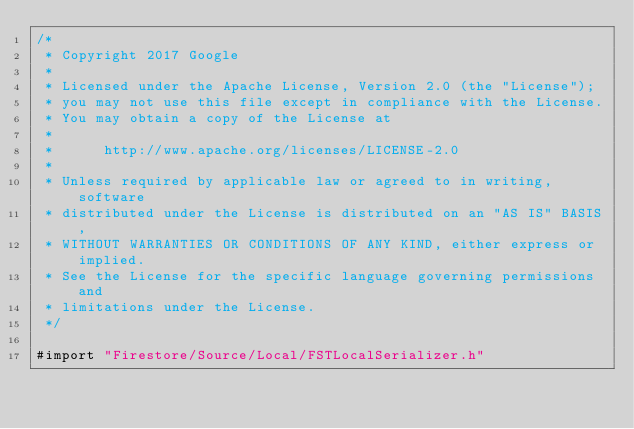Convert code to text. <code><loc_0><loc_0><loc_500><loc_500><_ObjectiveC_>/*
 * Copyright 2017 Google
 *
 * Licensed under the Apache License, Version 2.0 (the "License");
 * you may not use this file except in compliance with the License.
 * You may obtain a copy of the License at
 *
 *      http://www.apache.org/licenses/LICENSE-2.0
 *
 * Unless required by applicable law or agreed to in writing, software
 * distributed under the License is distributed on an "AS IS" BASIS,
 * WITHOUT WARRANTIES OR CONDITIONS OF ANY KIND, either express or implied.
 * See the License for the specific language governing permissions and
 * limitations under the License.
 */

#import "Firestore/Source/Local/FSTLocalSerializer.h"
</code> 